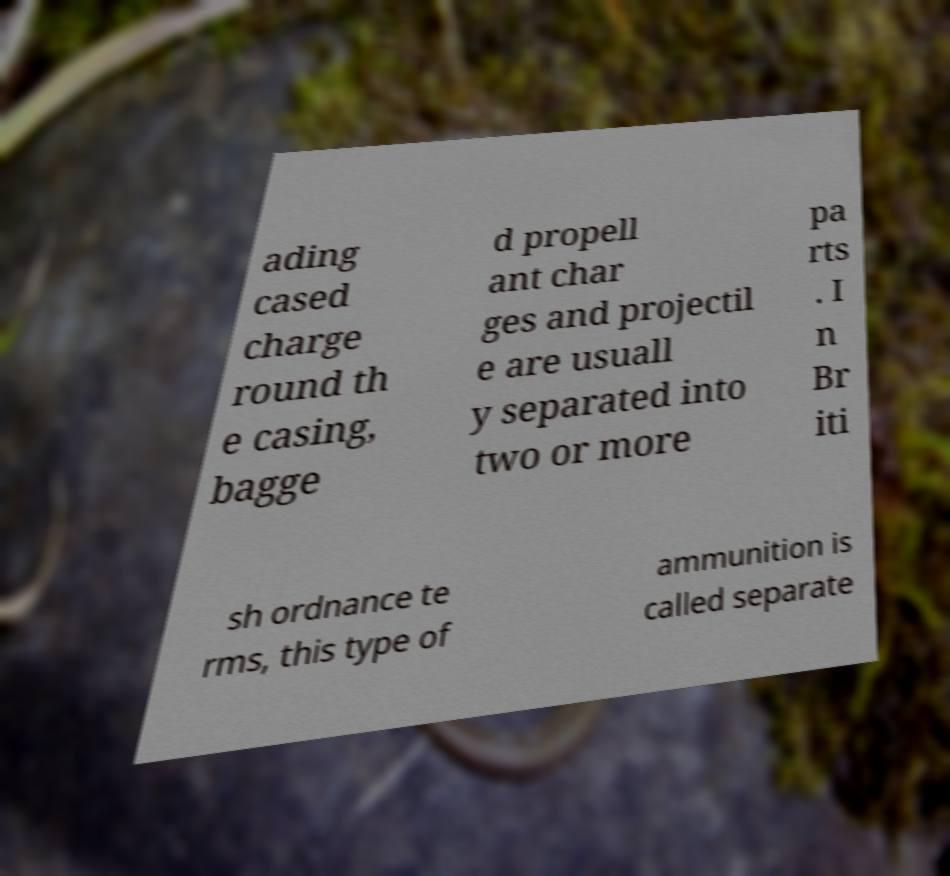For documentation purposes, I need the text within this image transcribed. Could you provide that? ading cased charge round th e casing, bagge d propell ant char ges and projectil e are usuall y separated into two or more pa rts . I n Br iti sh ordnance te rms, this type of ammunition is called separate 